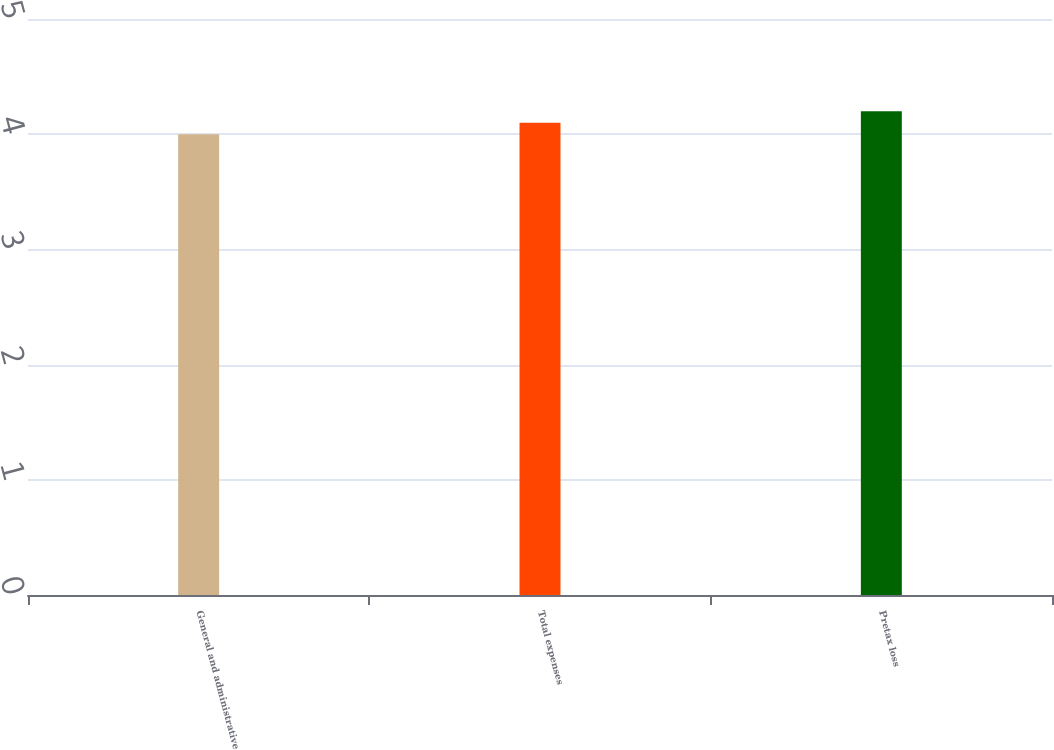Convert chart. <chart><loc_0><loc_0><loc_500><loc_500><bar_chart><fcel>General and administrative<fcel>Total expenses<fcel>Pretax loss<nl><fcel>4<fcel>4.1<fcel>4.2<nl></chart> 